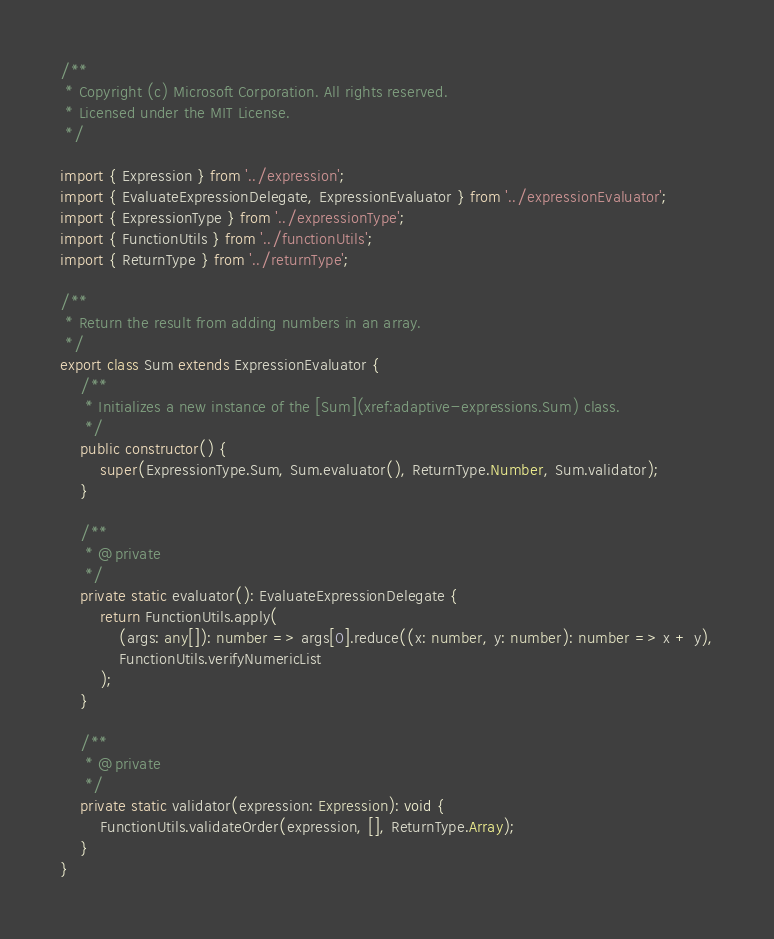Convert code to text. <code><loc_0><loc_0><loc_500><loc_500><_TypeScript_>/**
 * Copyright (c) Microsoft Corporation. All rights reserved.
 * Licensed under the MIT License.
 */

import { Expression } from '../expression';
import { EvaluateExpressionDelegate, ExpressionEvaluator } from '../expressionEvaluator';
import { ExpressionType } from '../expressionType';
import { FunctionUtils } from '../functionUtils';
import { ReturnType } from '../returnType';

/**
 * Return the result from adding numbers in an array.
 */
export class Sum extends ExpressionEvaluator {
    /**
     * Initializes a new instance of the [Sum](xref:adaptive-expressions.Sum) class.
     */
    public constructor() {
        super(ExpressionType.Sum, Sum.evaluator(), ReturnType.Number, Sum.validator);
    }

    /**
     * @private
     */
    private static evaluator(): EvaluateExpressionDelegate {
        return FunctionUtils.apply(
            (args: any[]): number => args[0].reduce((x: number, y: number): number => x + y),
            FunctionUtils.verifyNumericList
        );
    }

    /**
     * @private
     */
    private static validator(expression: Expression): void {
        FunctionUtils.validateOrder(expression, [], ReturnType.Array);
    }
}
</code> 